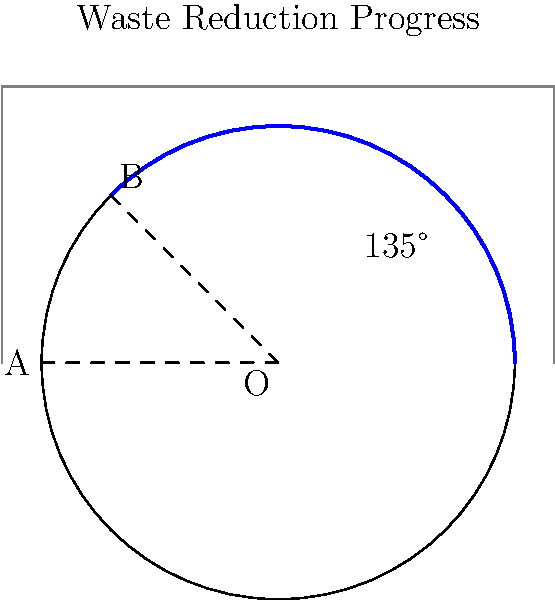In your circular waste reduction progress chart, the arc AB represents the percentage of waste reduced over the past quarter. If the radius of the circle is 6 meters and the central angle subtended by the arc is 135°, what is the length of the arc AB to the nearest tenth of a meter? To find the length of the arc AB, we'll follow these steps:

1) The formula for arc length is:
   $s = r\theta$
   where $s$ is the arc length, $r$ is the radius, and $\theta$ is the central angle in radians.

2) We're given the angle in degrees (135°), so we need to convert it to radians:
   $\theta = 135° \times \frac{\pi}{180°} = \frac{3\pi}{4}$ radians

3) Now we can substitute the values into our formula:
   $s = r\theta = 6 \times \frac{3\pi}{4}$

4) Simplify:
   $s = \frac{9\pi}{2} \approx 14.1371669...$

5) Rounding to the nearest tenth:
   $s \approx 14.1$ meters

Therefore, the length of the arc AB is approximately 14.1 meters.
Answer: 14.1 meters 